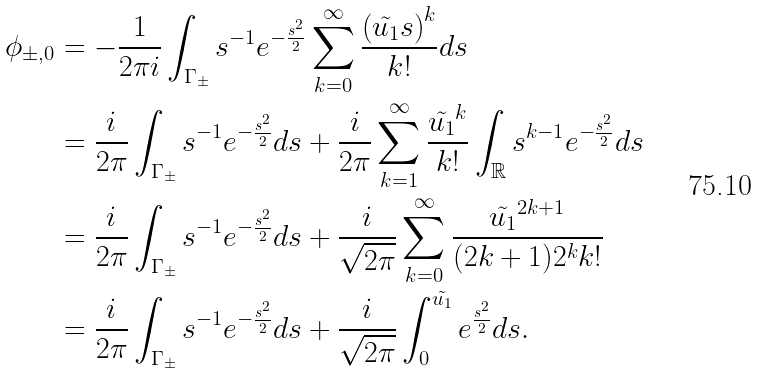Convert formula to latex. <formula><loc_0><loc_0><loc_500><loc_500>\phi _ { \pm , 0 } & = - \frac { 1 } { 2 \pi i } \int _ { \Gamma _ { \pm } } s ^ { - 1 } e ^ { - \frac { s ^ { 2 } } { 2 } } \sum _ { k = 0 } ^ { \infty } \frac { \left ( \tilde { u _ { 1 } } s \right ) ^ { k } } { k ! } d s \\ & = \frac { i } { 2 \pi } \int _ { \Gamma _ { \pm } } s ^ { - 1 } e ^ { - \frac { s ^ { 2 } } { 2 } } d s + \frac { i } { 2 \pi } \sum _ { k = 1 } ^ { \infty } \frac { \tilde { u _ { 1 } } ^ { k } } { k ! } \int _ { \mathbb { R } } s ^ { k - 1 } e ^ { - \frac { s ^ { 2 } } { 2 } } d s \\ & = \frac { i } { 2 \pi } \int _ { \Gamma _ { \pm } } s ^ { - 1 } e ^ { - \frac { s ^ { 2 } } { 2 } } d s + \frac { i } { \sqrt { 2 \pi } } \sum _ { k = 0 } ^ { \infty } \frac { \tilde { u _ { 1 } } ^ { 2 k + 1 } } { ( 2 k + 1 ) 2 ^ { k } k ! } \\ & = \frac { i } { 2 \pi } \int _ { \Gamma _ { \pm } } s ^ { - 1 } e ^ { - \frac { s ^ { 2 } } { 2 } } d s + \frac { i } { \sqrt { 2 \pi } } \int _ { 0 } ^ { \tilde { u _ { 1 } } } e ^ { \frac { s ^ { 2 } } { 2 } } d s .</formula> 